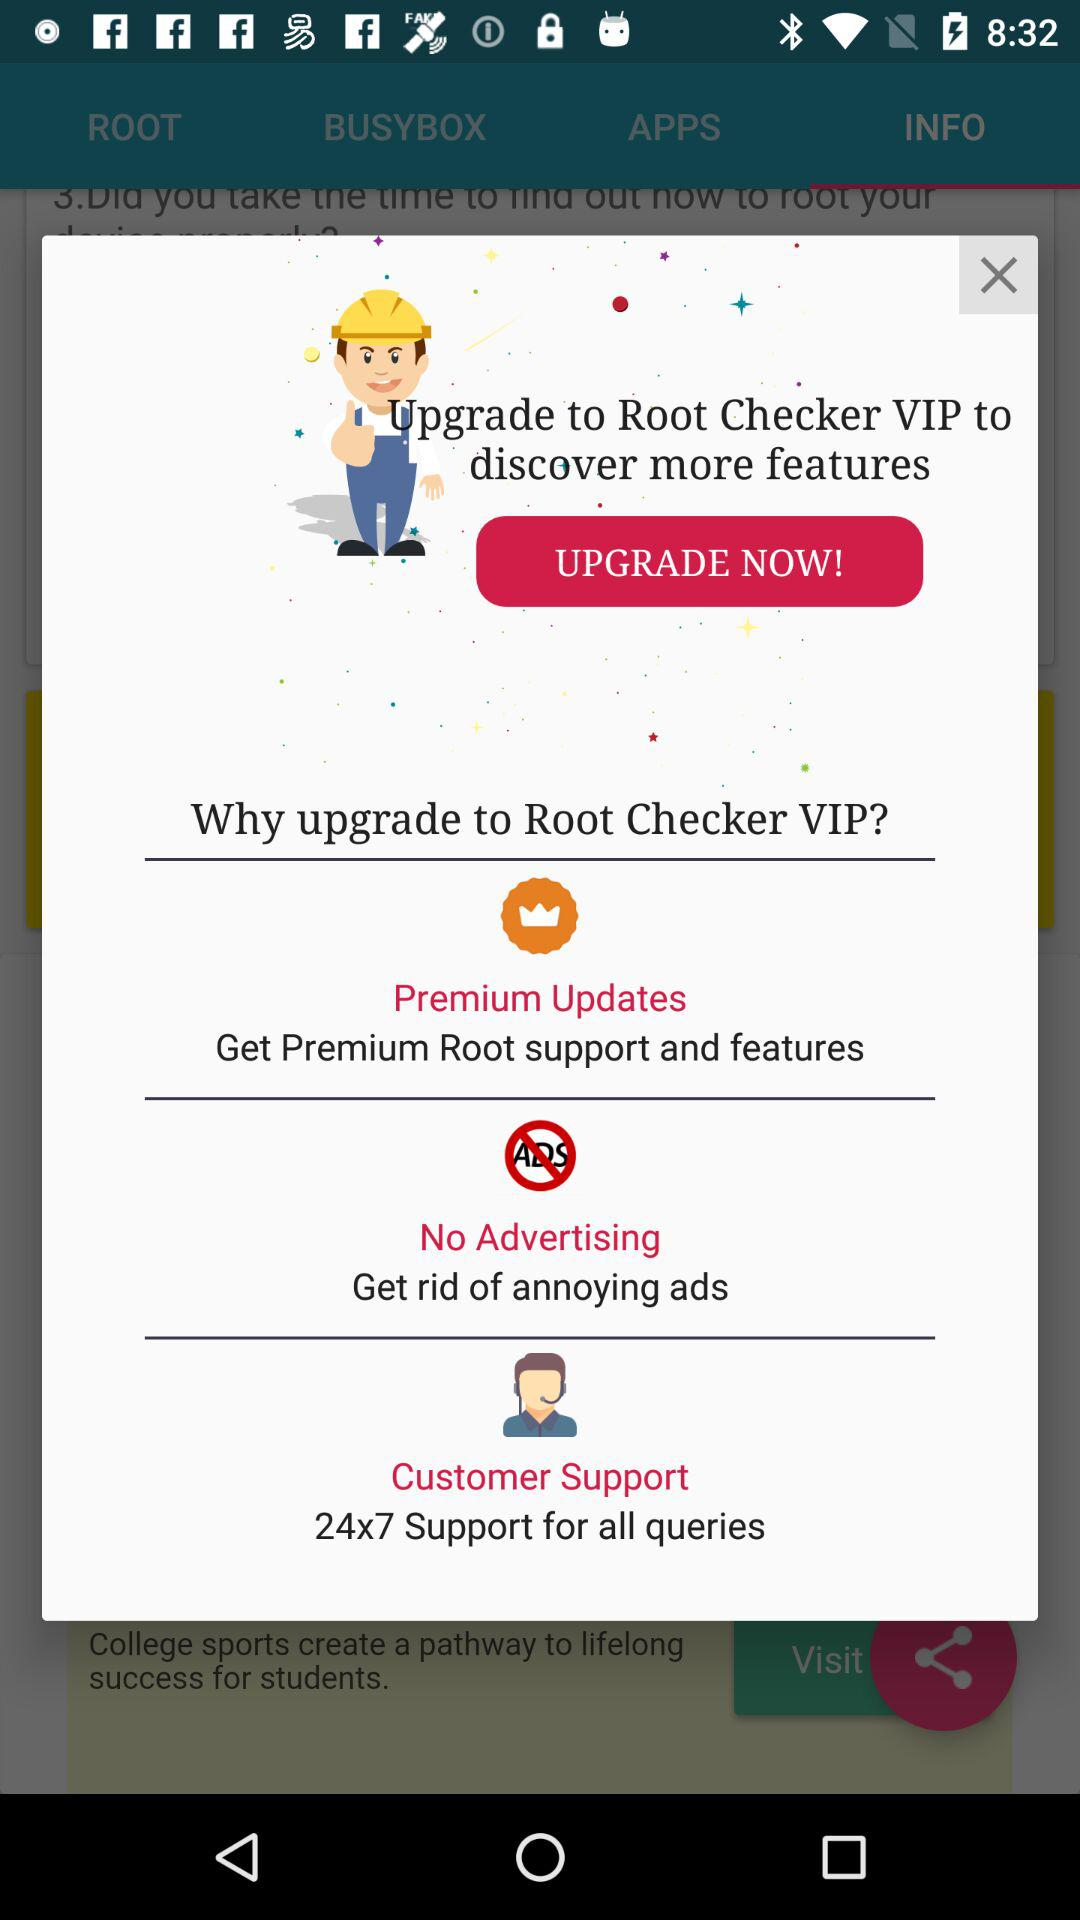How much is the upgrade?
When the provided information is insufficient, respond with <no answer>. <no answer> 